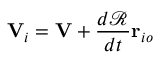Convert formula to latex. <formula><loc_0><loc_0><loc_500><loc_500>V _ { i } = V + { \frac { d { \mathcal { R } } } { d t } } r _ { i o }</formula> 